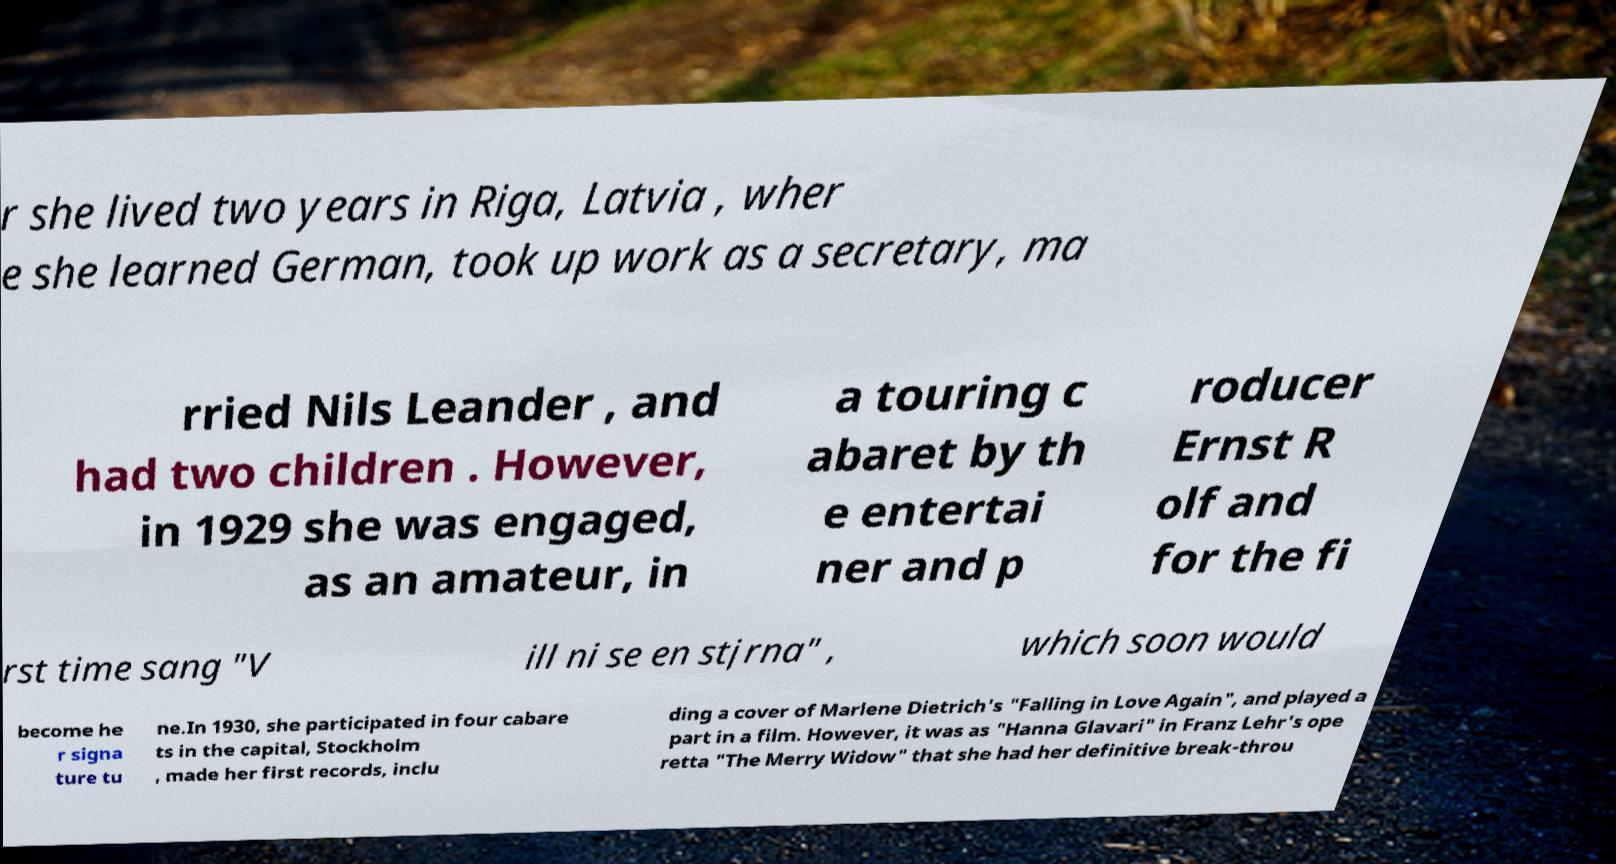Could you assist in decoding the text presented in this image and type it out clearly? r she lived two years in Riga, Latvia , wher e she learned German, took up work as a secretary, ma rried Nils Leander , and had two children . However, in 1929 she was engaged, as an amateur, in a touring c abaret by th e entertai ner and p roducer Ernst R olf and for the fi rst time sang "V ill ni se en stjrna" , which soon would become he r signa ture tu ne.In 1930, she participated in four cabare ts in the capital, Stockholm , made her first records, inclu ding a cover of Marlene Dietrich's "Falling in Love Again", and played a part in a film. However, it was as "Hanna Glavari" in Franz Lehr's ope retta "The Merry Widow" that she had her definitive break-throu 